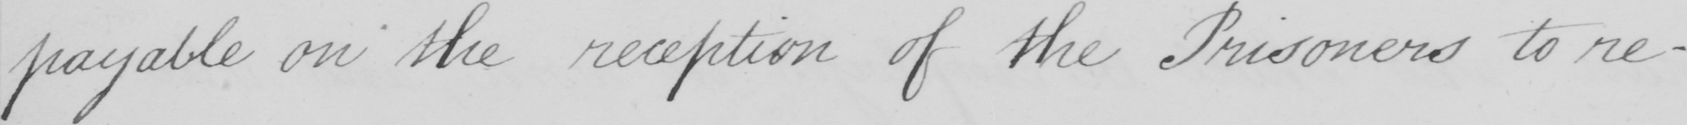What text is written in this handwritten line? payable on the reception of the Prisoners to re- 